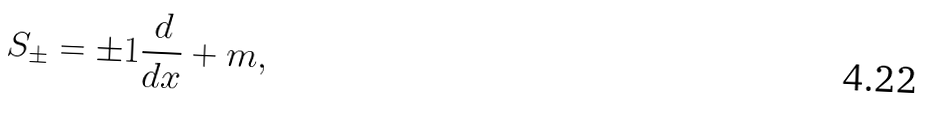Convert formula to latex. <formula><loc_0><loc_0><loc_500><loc_500>S _ { \pm } = \pm { 1 } \frac { d } { d x } + { m } ,</formula> 